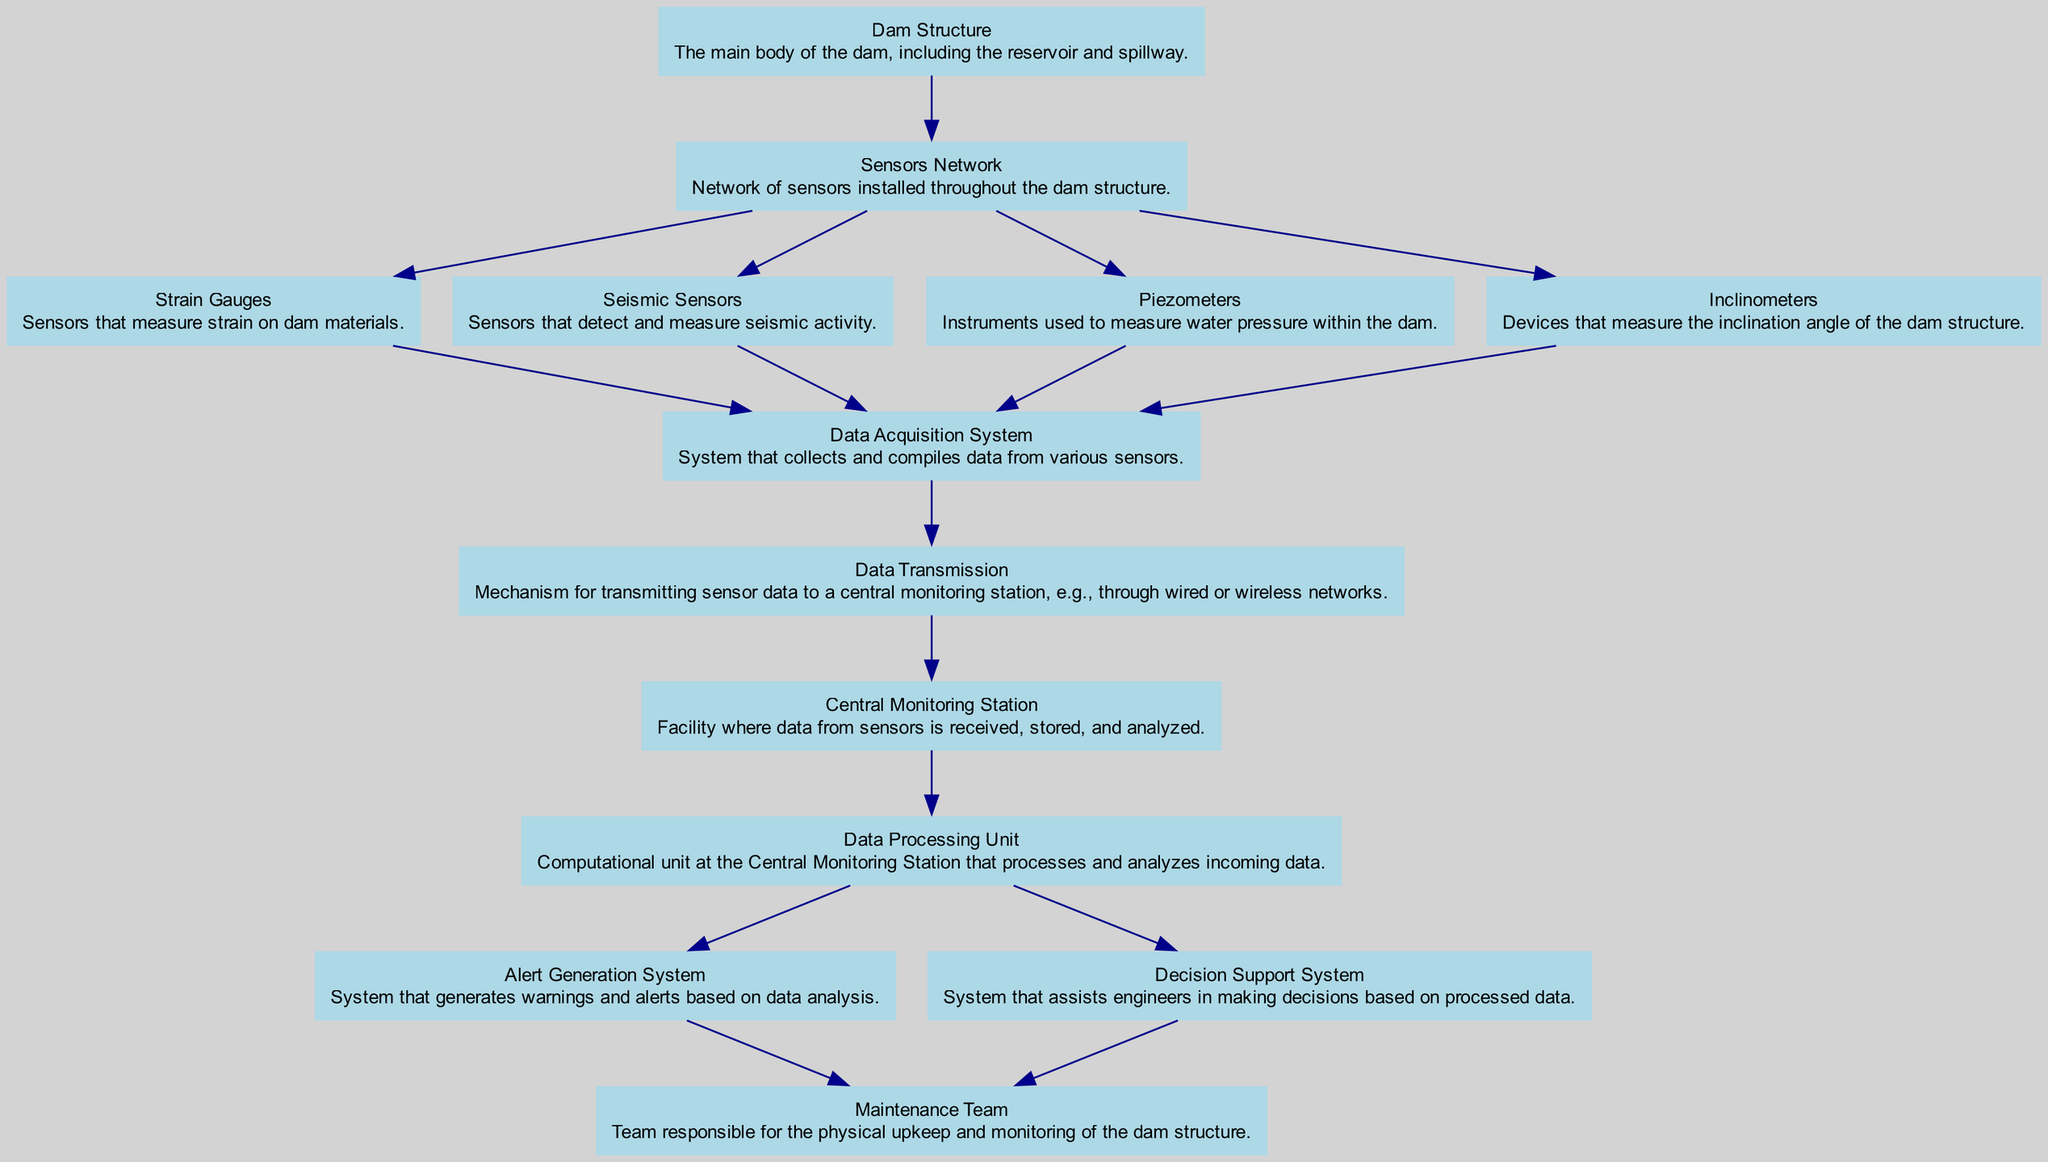What is the main body of the dam called? The diagram labels the main body of the dam as the "Dam Structure," which is the primary component highlighted at the top of the diagram.
Answer: Dam Structure How many types of sensors are in the Sensors Network? The diagram indicates that there are four types of sensors within the "Sensors Network": Strain Gauges, Seismic Sensors, Piezometers, and Inclinometers, all connected to the Sensors Network node.
Answer: Four What is the role of the Data Acquisition System? The "Data Acquisition System" is shown to be connected to multiple sensors, indicating that its role is to collect and compile data from the Strain Gauges, Seismic Sensors, Piezometers, and Inclinometers.
Answer: Collects and compiles data What is the final output from the Data Processing Unit? According to the diagram, the "Data Processing Unit" provides input to both the "Alert Generation System" and the "Decision Support System," indicating that its outputs are warnings/alerts and decision-making support for engineers.
Answer: Alerts and decision support Which element receives data from the Data Transmission? The diagram shows that the "Central Monitoring Station" receives data directly from the "Data Transmission" node, illustrating that it is the next step in the data flow after transmission.
Answer: Central Monitoring Station How does the maintenance team receive alerts? The diagram indicates that the "Alert Generation System" is connected to the "Maintenance Team," meaning that this system generates alerts that are directed to the maintenance team for action when needed.
Answer: Alert Generation System Which sensors measure the angle of the dam structure? The "Inclinometers" are specifically labeled in the diagram as the devices that measure the inclination angle of the dam structure, distinguishing their function from the other sensors.
Answer: Inclinometers What process occurs after water pressure measurement? Once the "Piezometers" measure water pressure within the dam, the data flows to the "Data Acquisition System," indicating a direct link between the piezometers and the collection of data for further processing.
Answer: Data Acquisition System 